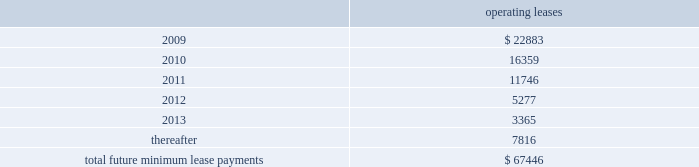Notes to consolidated financial statements 2014 ( continued ) note 12 2014related party transactions in the course of settling money transfer transactions , we purchase foreign currency from consultoria internacional casa de cambio ( 201ccisa 201d ) , a mexican company partially owned by certain of our employees .
As of march 31 , 2008 , mr .
Ra fal lim f3n cortes , a 10% ( 10 % ) shareholder of cisa , was no longer an employee , and we no longer considered cisa a related party .
We purchased 6.1 billion mexican pesos for $ 560.3 million during the ten months ended march 31 , 2008 and 8.1 billion mexican pesos for $ 736.0 million during fiscal 2007 from cisa .
We believe these currency transactions were executed at prevailing market exchange rates .
Also from time to time , money transfer transactions are settled at destination facilities owned by cisa .
We incurred related settlement expenses , included in cost of service in the accompanying consolidated statements of income of $ 0.5 million in the ten months ended march 31 , 2008 .
In fiscal 2007 and 2006 , we incurred related settlement expenses , included in cost of service in the accompanying consolidated statements of income of $ 0.7 and $ 0.6 million , respectively .
In the normal course of business , we periodically utilize the services of contractors to provide software development services .
One of our employees , hired in april 2005 , is also an employee , officer , and part owner of a firm that provides such services .
The services provided by this firm primarily relate to software development in connection with our planned next generation front-end processing system in the united states .
During fiscal 2008 , we capitalized fees paid to this firm of $ 0.3 million .
As of may 31 , 2008 and 2007 , capitalized amounts paid to this firm of $ 4.9 million and $ 4.6 million , respectively , were included in property and equipment in the accompanying consolidated balance sheets .
In addition , we expensed amounts paid to this firm of $ 0.3 million , $ 0.1 million and $ 0.5 million in the years ended may 31 , 2008 , 2007 and 2006 , respectively .
Note 13 2014commitments and contingencies leases we conduct a major part of our operations using leased facilities and equipment .
Many of these leases have renewal and purchase options and provide that we pay the cost of property taxes , insurance and maintenance .
Rent expense on all operating leases for fiscal 2008 , 2007 and 2006 was $ 30.4 million , $ 27.1 million , and $ 24.4 million , respectively .
Future minimum lease payments for all noncancelable leases at may 31 , 2008 were as follows : operating leases .
We are party to a number of other claims and lawsuits incidental to our business .
In the opinion of management , the reasonably possible outcome of such matters , individually or in the aggregate , will not have a material adverse impact on our financial position , liquidity or results of operations. .
What percentage of the future lease payments is has to be paid in 2009? 
Rationale: to figure out the percentage paid in 2009 , one must take the amount to be paid in 2009 and divide by the total amount to be paid .
Computations: (22883 / 67446)
Answer: 0.33928. 